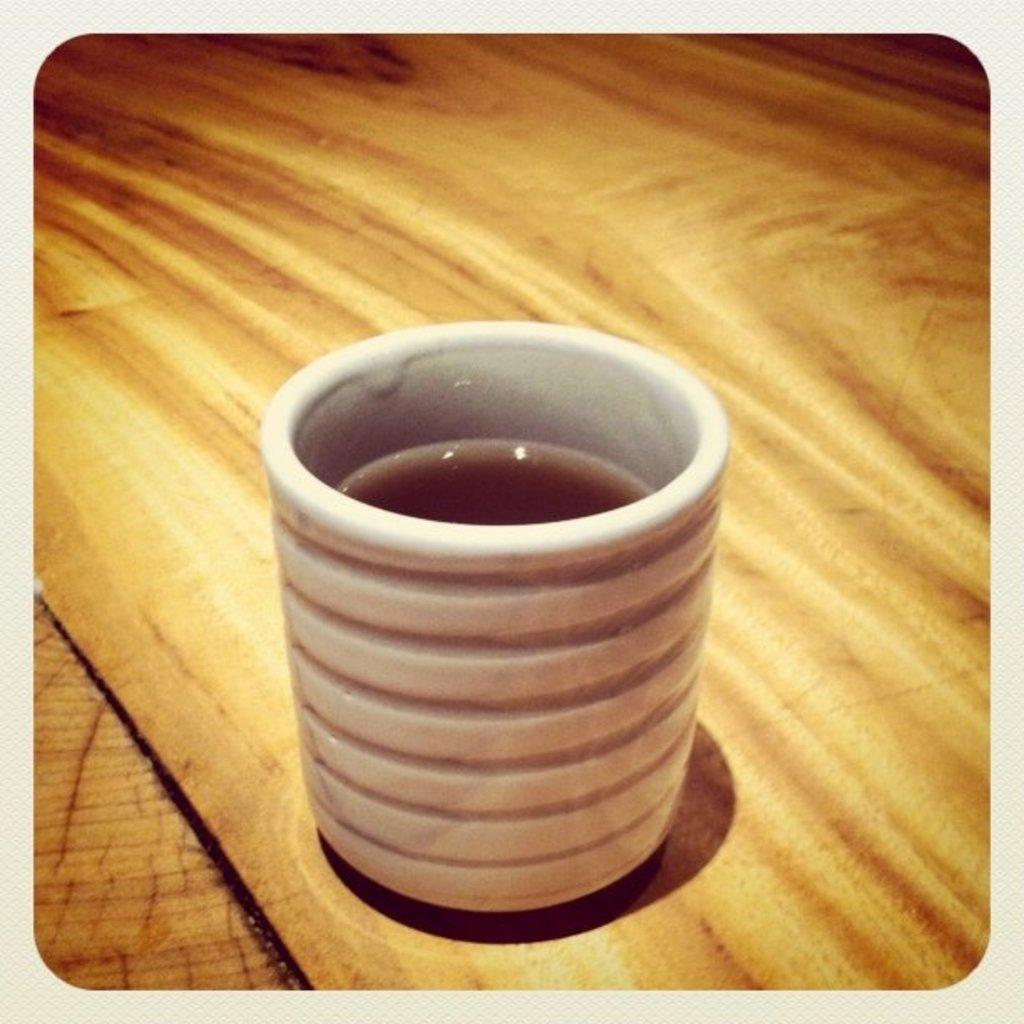What object is present in the image that can hold liquid? There is a cup in the image that can hold liquid. What is inside the cup? The cup contains liquid. Where is the cup located in the image? The cup is on a platform. How many dolls are sitting on the platform next to the cup? There are no dolls present in the image; only a cup containing liquid and a platform are visible. 